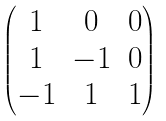<formula> <loc_0><loc_0><loc_500><loc_500>\begin{pmatrix} 1 & 0 & 0 \\ 1 & - 1 & 0 \\ - 1 & 1 & 1 \end{pmatrix}</formula> 